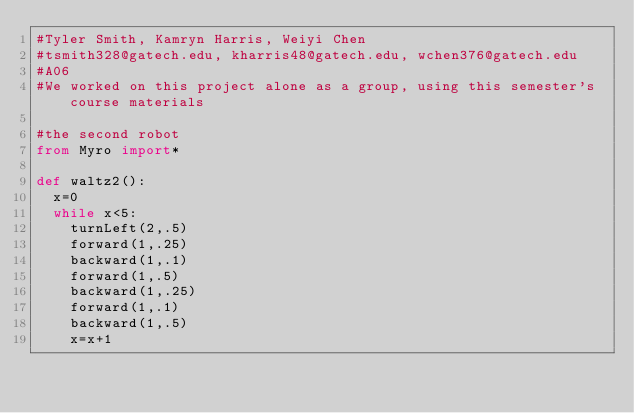Convert code to text. <code><loc_0><loc_0><loc_500><loc_500><_Python_>#Tyler Smith, Kamryn Harris, Weiyi Chen
#tsmith328@gatech.edu, kharris48@gatech.edu, wchen376@gatech.edu
#A06
#We worked on this project alone as a group, using this semester's course materials

#the second robot
from Myro import*

def waltz2():
  x=0
  while x<5:
    turnLeft(2,.5)
    forward(1,.25)
    backward(1,.1)
    forward(1,.5)
    backward(1,.25)
    forward(1,.1)
    backward(1,.5)
    x=x+1</code> 